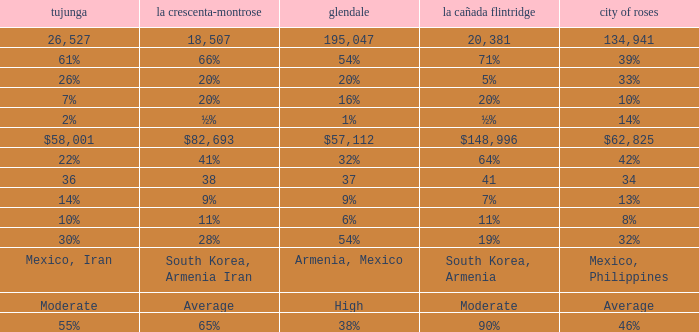What is the percentage of Tukunga when La Crescenta-Montrose is 28%? 30%. 